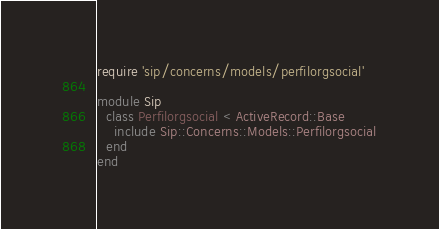Convert code to text. <code><loc_0><loc_0><loc_500><loc_500><_Ruby_>
require 'sip/concerns/models/perfilorgsocial'

module Sip
  class Perfilorgsocial < ActiveRecord::Base
    include Sip::Concerns::Models::Perfilorgsocial
  end
end
</code> 